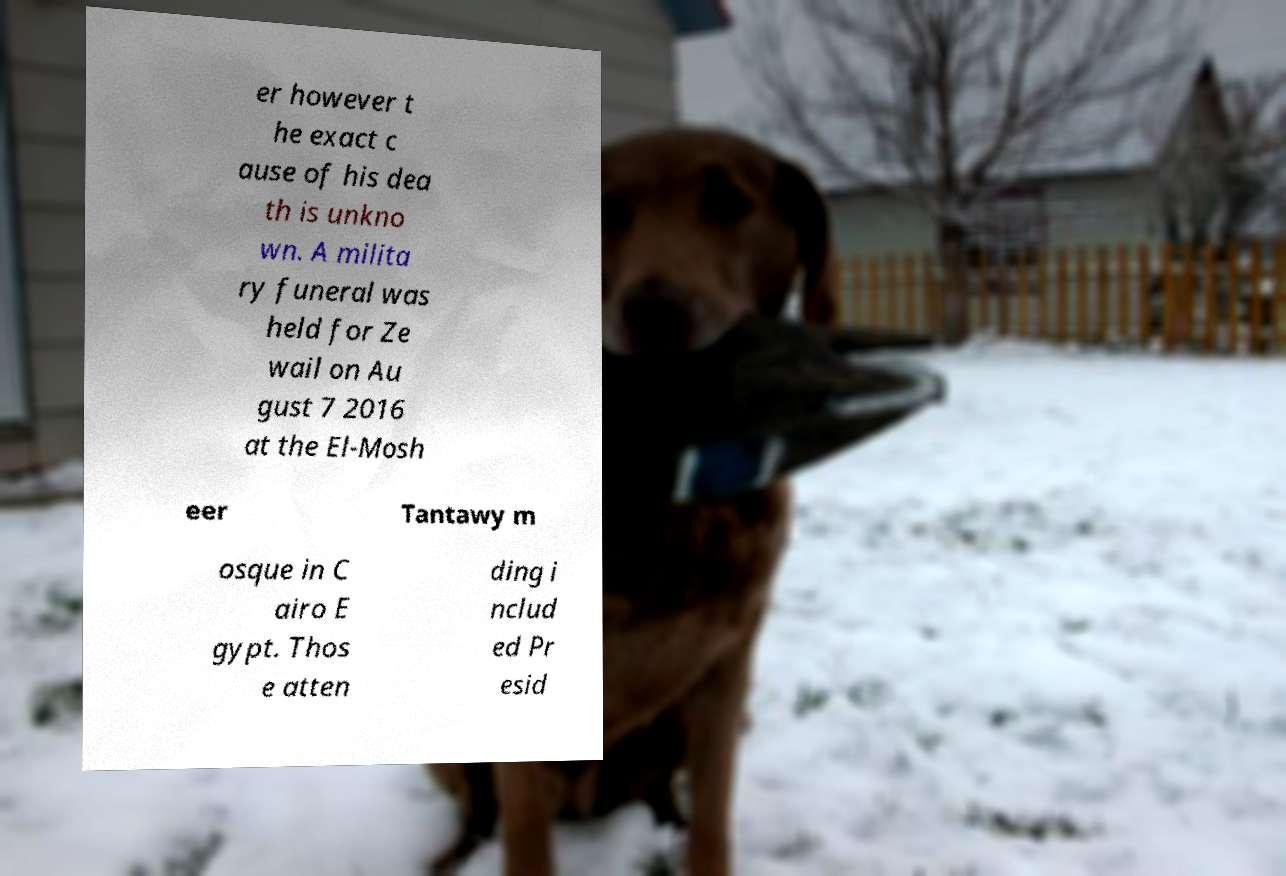Please read and relay the text visible in this image. What does it say? er however t he exact c ause of his dea th is unkno wn. A milita ry funeral was held for Ze wail on Au gust 7 2016 at the El-Mosh eer Tantawy m osque in C airo E gypt. Thos e atten ding i nclud ed Pr esid 